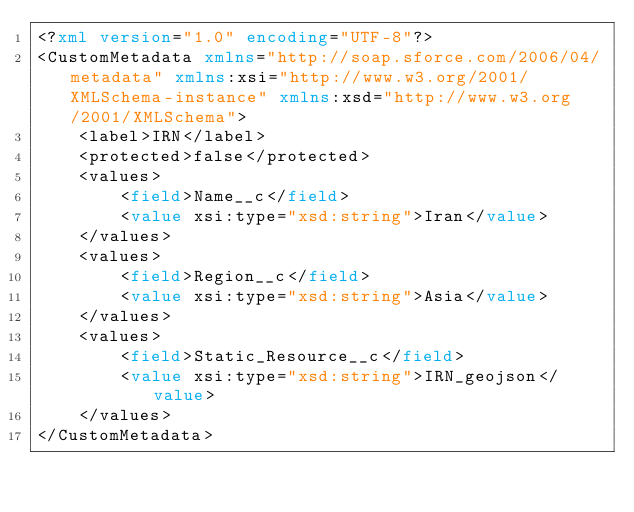<code> <loc_0><loc_0><loc_500><loc_500><_XML_><?xml version="1.0" encoding="UTF-8"?>
<CustomMetadata xmlns="http://soap.sforce.com/2006/04/metadata" xmlns:xsi="http://www.w3.org/2001/XMLSchema-instance" xmlns:xsd="http://www.w3.org/2001/XMLSchema">
    <label>IRN</label>
    <protected>false</protected>
    <values>
        <field>Name__c</field>
        <value xsi:type="xsd:string">Iran</value>
    </values>
    <values>
        <field>Region__c</field>
        <value xsi:type="xsd:string">Asia</value>
    </values>
    <values>
        <field>Static_Resource__c</field>
        <value xsi:type="xsd:string">IRN_geojson</value>
    </values>
</CustomMetadata>
</code> 